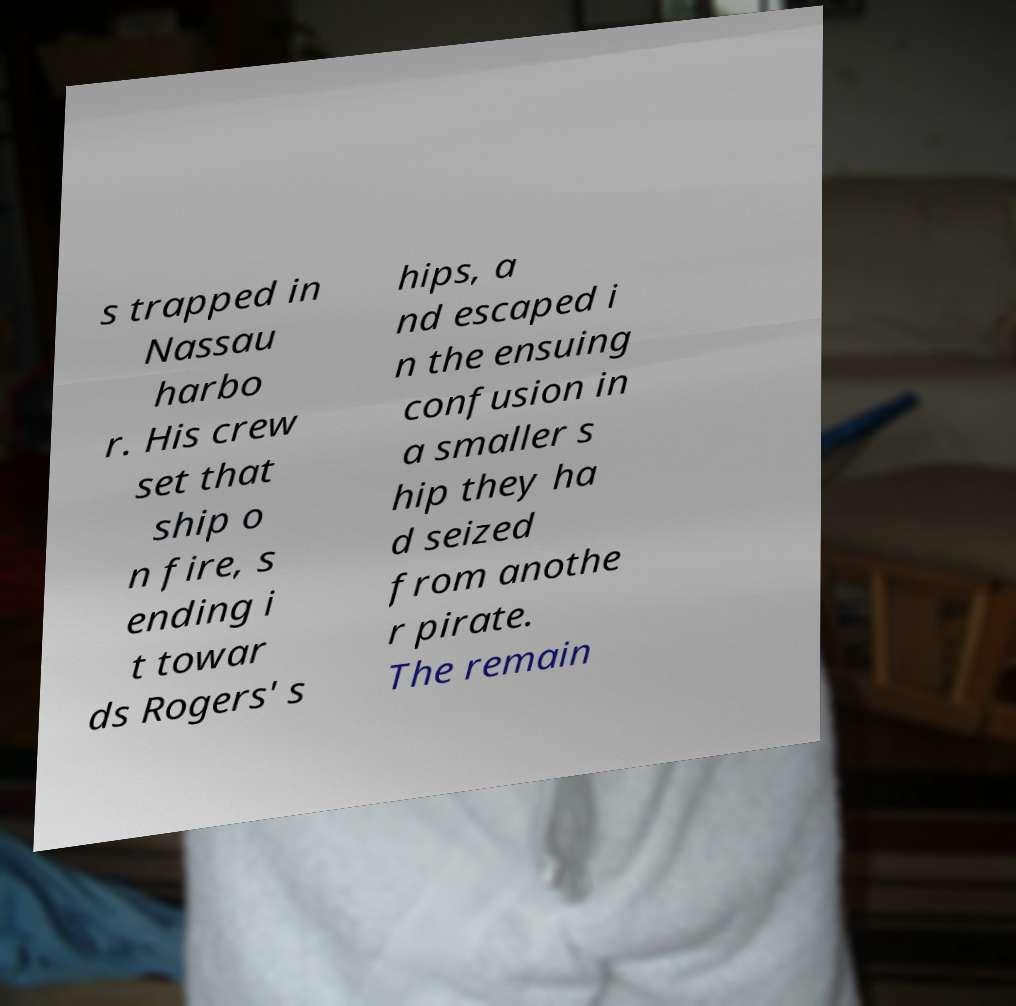What messages or text are displayed in this image? I need them in a readable, typed format. s trapped in Nassau harbo r. His crew set that ship o n fire, s ending i t towar ds Rogers' s hips, a nd escaped i n the ensuing confusion in a smaller s hip they ha d seized from anothe r pirate. The remain 